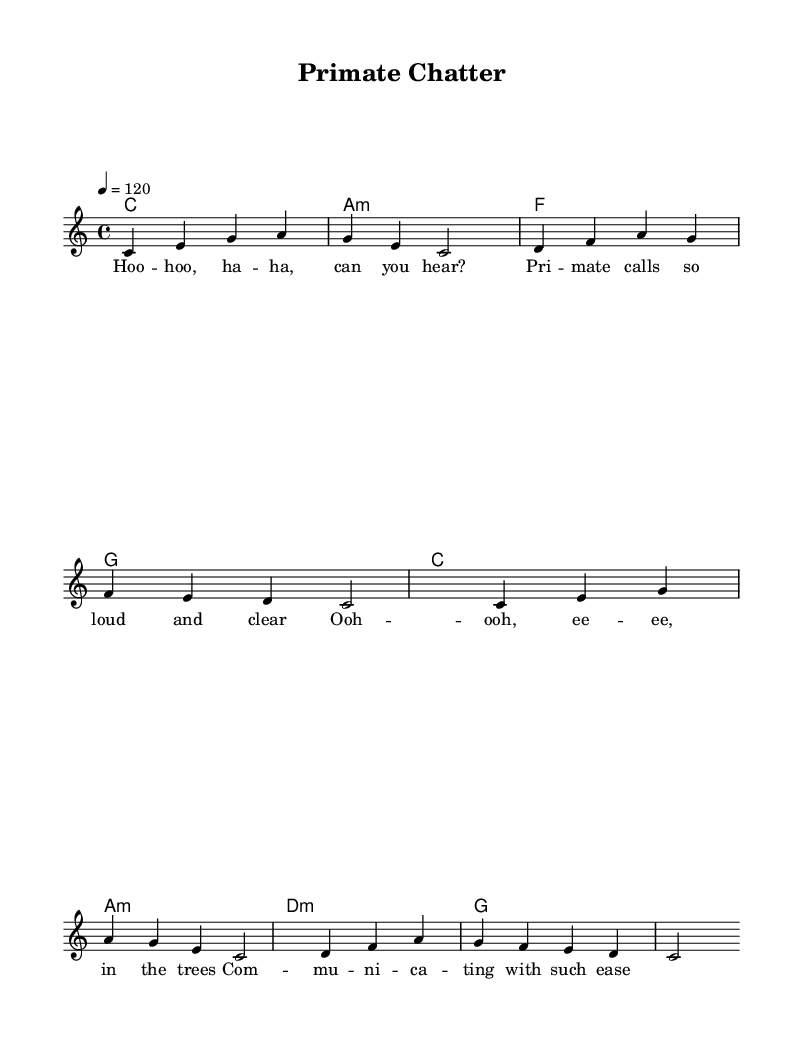What is the key signature of this music? The key signature is C major, which has no sharps or flats.
Answer: C major What is the time signature of this music? The time signature is indicated as 4/4, meaning there are four beats in each measure and a quarter note receives one beat.
Answer: 4/4 What is the tempo marking of this piece? The tempo marking is 4 = 120, which indicates that the beat is set to 120 quarter-note beats per minute.
Answer: 120 How many measures are present in the melody? The melody consists of four measures each containing four beats, leading to a total of the same four measures represented in a block.
Answer: Four What is the lyric's first line? The first line of the lyrics is "Hoo -- hoo, ha -- ha, can you hear?" which is shown explicitly beneath the melody notes.
Answer: Hoo -- hoo, ha -- ha, can you hear? How many chords are used in the harmonies section? The chords listed in the harmonies section include four different chord types: C, A minor, F, and G, which form the repetitive sequence within the structure.
Answer: Four What is the main theme of the lyrics? The lyrics discuss primate calls and communication, emphasizing the clarity and ease of their vocalizations in the trees.
Answer: Primate communication 